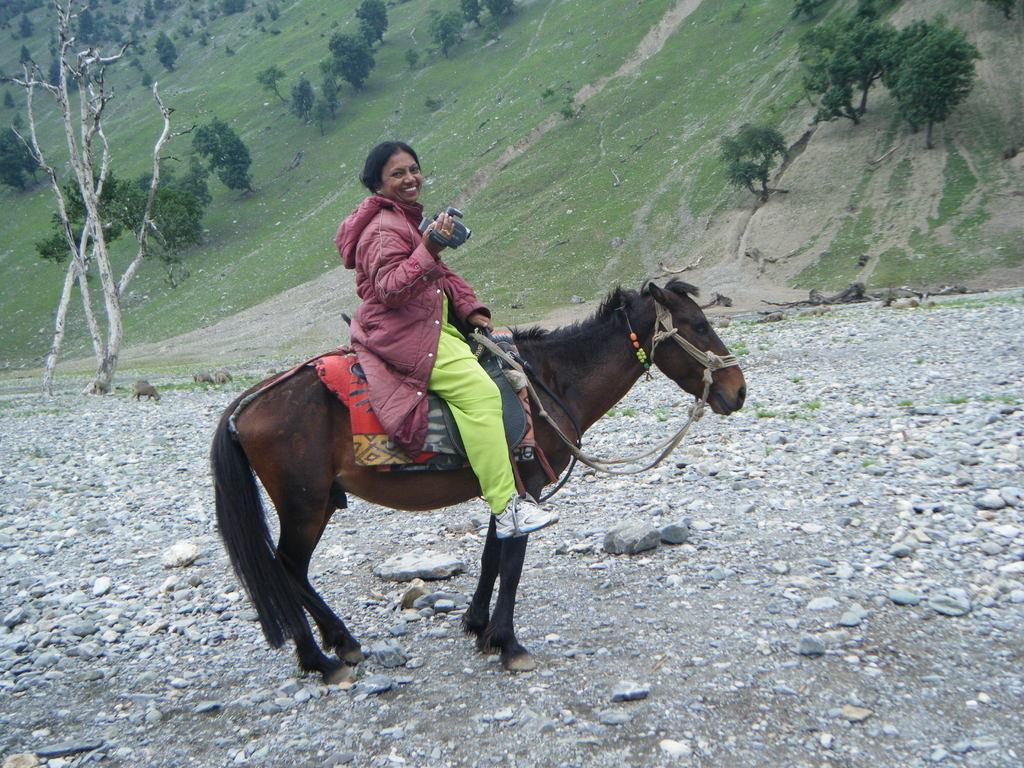Who is the main subject in the image? There is a woman in the image. What is the woman doing in the image? The woman is sitting on a horse. What is the woman holding in the image? The woman is holding a camera. What type of terrain is visible at the bottom of the image? There are stones at the bottom of the image. What type of vegetation can be seen in the background of the image? There is grass and trees visible in the background of the image. What type of tooth is visible in the image? There is no tooth visible in the image. What hobbies does the woman have, based on the items she is holding in the image? We cannot determine the woman's hobbies based solely on the items she is holding in the image. Is there a doctor present in the image? There is no mention of a doctor in the image. 